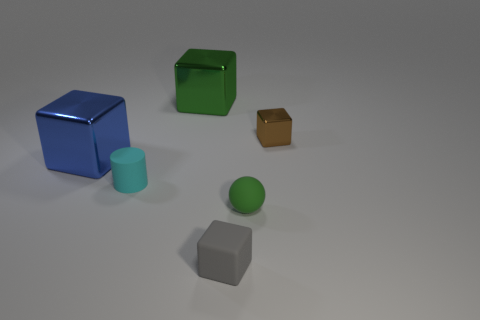Add 2 small cyan matte objects. How many objects exist? 8 Subtract all cylinders. How many objects are left? 5 Add 6 cyan matte cylinders. How many cyan matte cylinders exist? 7 Subtract 0 purple spheres. How many objects are left? 6 Subtract all green matte things. Subtract all small matte objects. How many objects are left? 2 Add 2 tiny brown shiny things. How many tiny brown shiny things are left? 3 